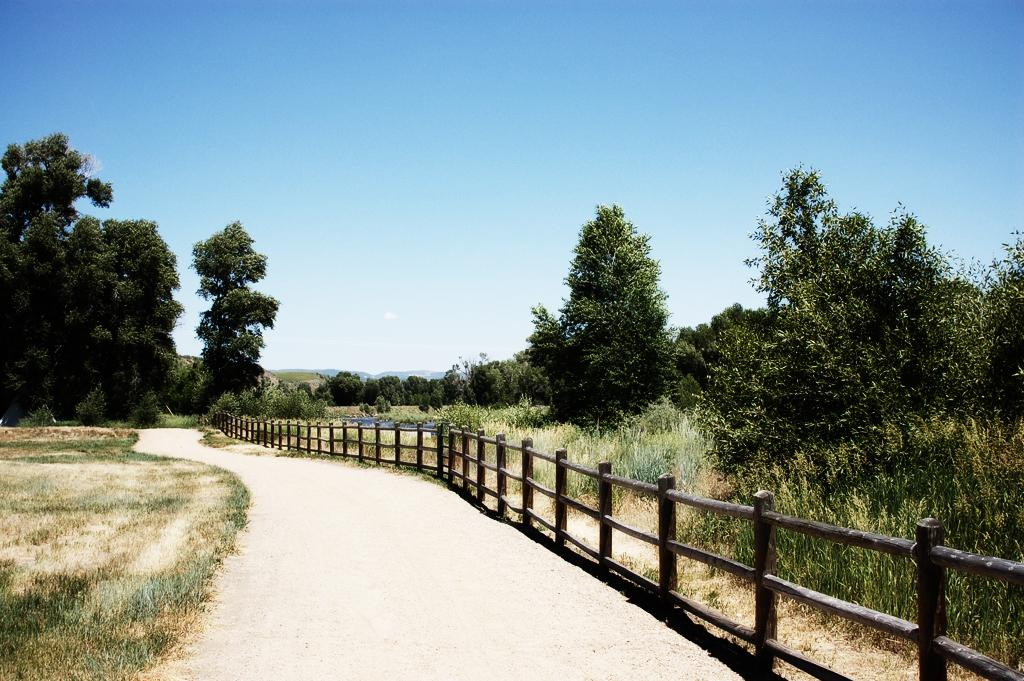What is located in the center of the image? There is a walkway in the center of the image. What can be seen on the right side of the image? There is a fence on the right side of the image. What type of vegetation is visible in the background of the image? There are trees and grass in the background of the image. What geographical features can be seen in the background of the image? There are hills in the background of the image. What is visible in the sky in the background of the image? The sky is visible in the background of the image. What type of book is the beast reading in the image? There is no beast or book present in the image. Can you tell me how the people in the image are talking to each other? There are no people visible in the image, so it is not possible to determine how they might be talking to each other. 